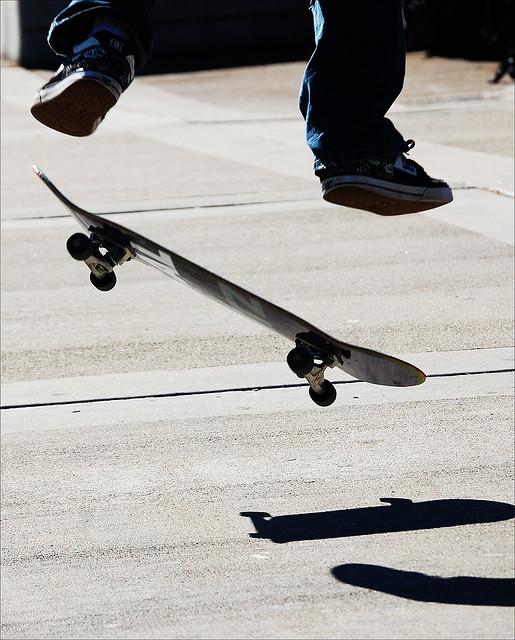What is this trick called on a skateboard?
Be succinct. Jump. Is the skateboarder wearing jeans?
Be succinct. Yes. Can one see the shadow of the skateboard?
Short answer required. Yes. 